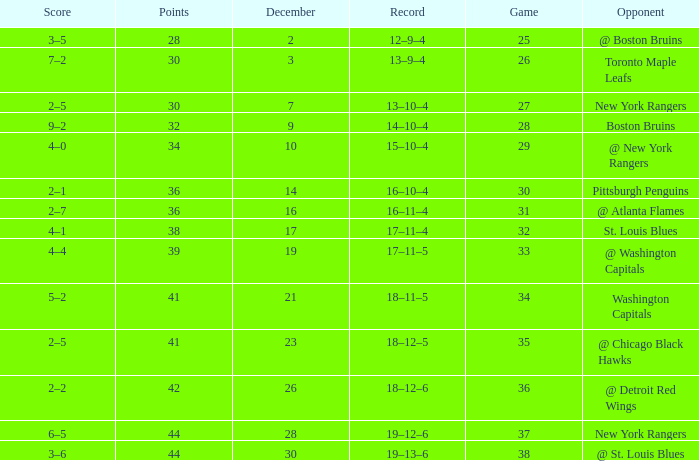Which Game has a Record of 14–10–4, and Points smaller than 32? None. 